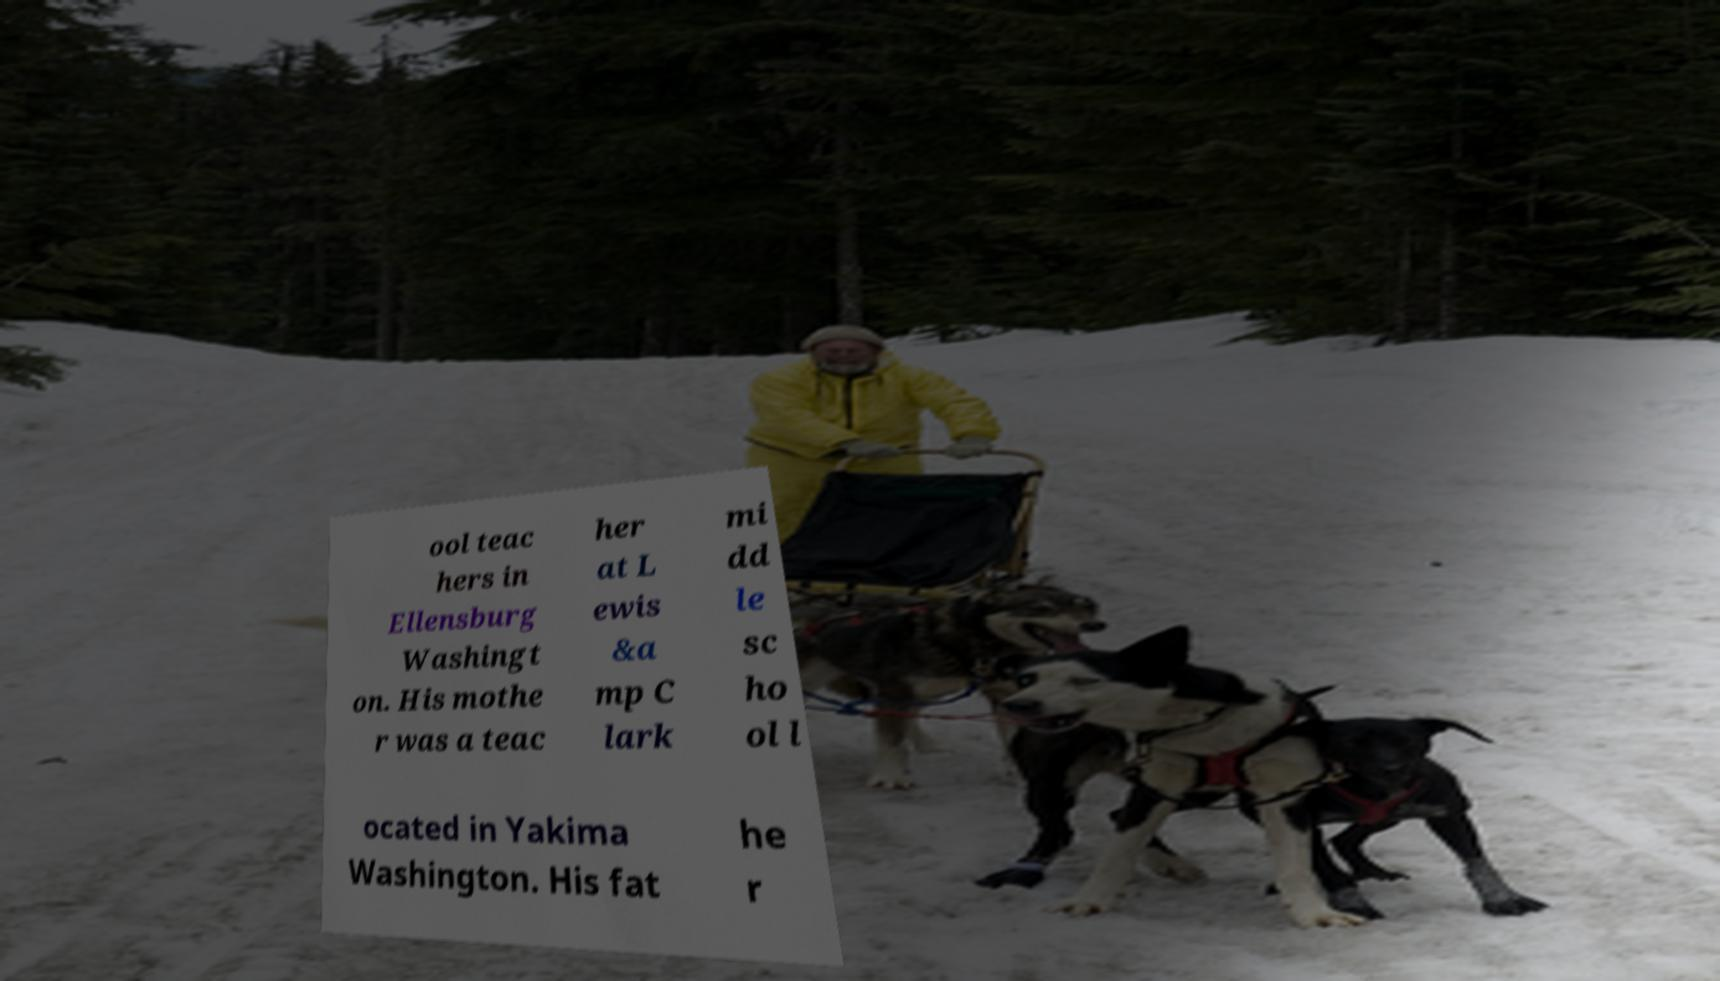There's text embedded in this image that I need extracted. Can you transcribe it verbatim? ool teac hers in Ellensburg Washingt on. His mothe r was a teac her at L ewis &a mp C lark mi dd le sc ho ol l ocated in Yakima Washington. His fat he r 